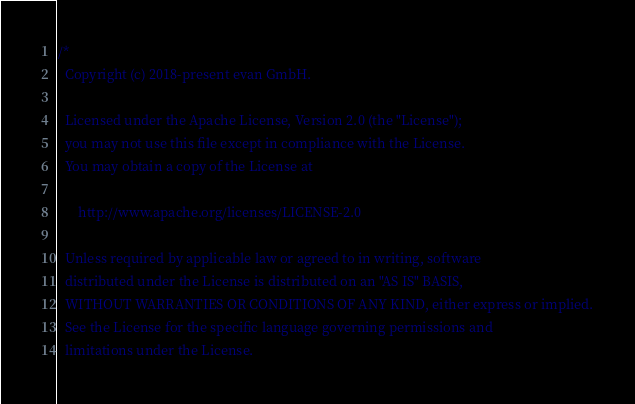<code> <loc_0><loc_0><loc_500><loc_500><_Rust_>/*
  Copyright (c) 2018-present evan GmbH.

  Licensed under the Apache License, Version 2.0 (the "License");
  you may not use this file except in compliance with the License.
  You may obtain a copy of the License at

      http://www.apache.org/licenses/LICENSE-2.0

  Unless required by applicable law or agreed to in writing, software
  distributed under the License is distributed on an "AS IS" BASIS,
  WITHOUT WARRANTIES OR CONDITIONS OF ANY KIND, either express or implied.
  See the License for the specific language governing permissions and
  limitations under the License.</code> 